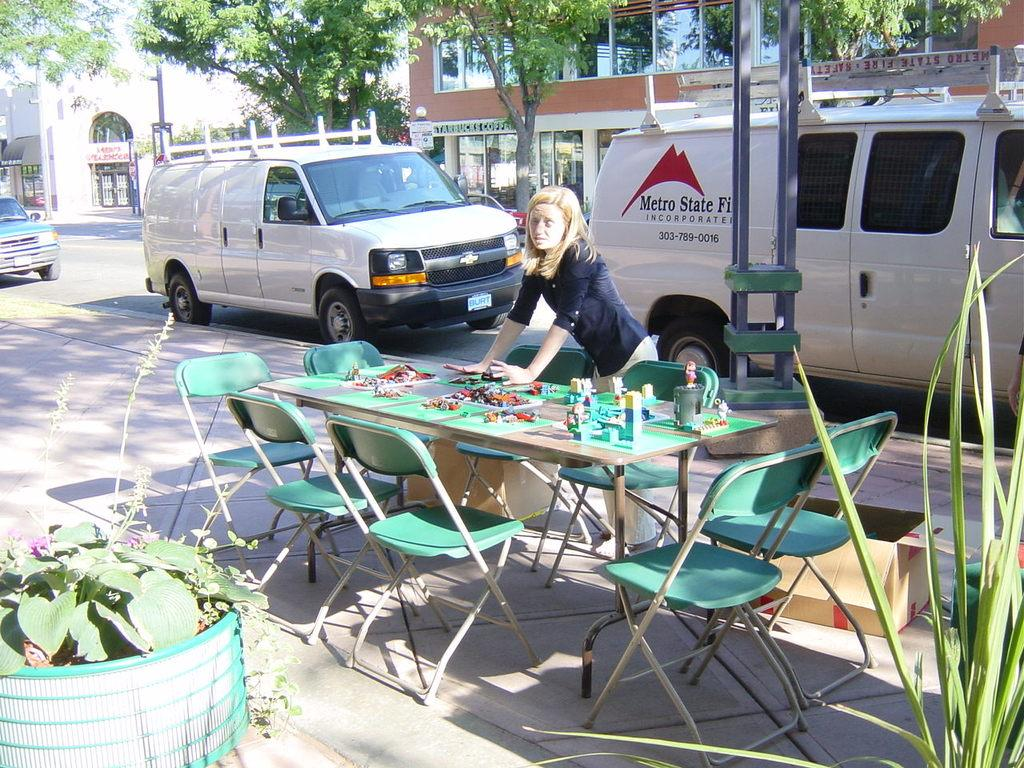<image>
Create a compact narrative representing the image presented. A woman setting a table in front of a white van that reads Metro State on the side. 